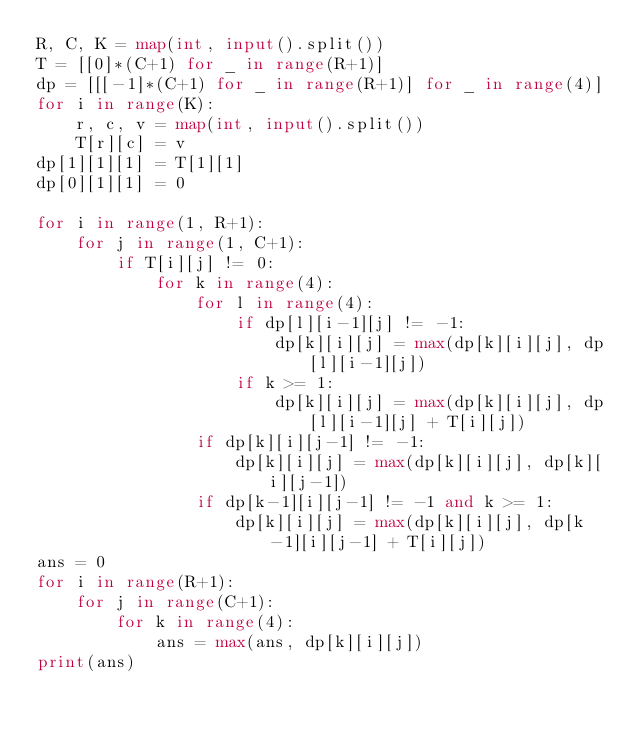Convert code to text. <code><loc_0><loc_0><loc_500><loc_500><_Python_>R, C, K = map(int, input().split())
T = [[0]*(C+1) for _ in range(R+1)]
dp = [[[-1]*(C+1) for _ in range(R+1)] for _ in range(4)]
for i in range(K):
    r, c, v = map(int, input().split())
    T[r][c] = v
dp[1][1][1] = T[1][1]
dp[0][1][1] = 0

for i in range(1, R+1):
    for j in range(1, C+1):
        if T[i][j] != 0:
            for k in range(4):
                for l in range(4):
                    if dp[l][i-1][j] != -1:
                        dp[k][i][j] = max(dp[k][i][j], dp[l][i-1][j])
                    if k >= 1:
                        dp[k][i][j] = max(dp[k][i][j], dp[l][i-1][j] + T[i][j])
                if dp[k][i][j-1] != -1:
                    dp[k][i][j] = max(dp[k][i][j], dp[k][i][j-1])
                if dp[k-1][i][j-1] != -1 and k >= 1:
                    dp[k][i][j] = max(dp[k][i][j], dp[k-1][i][j-1] + T[i][j])
ans = 0
for i in range(R+1):
    for j in range(C+1):
        for k in range(4):
            ans = max(ans, dp[k][i][j])
print(ans)</code> 